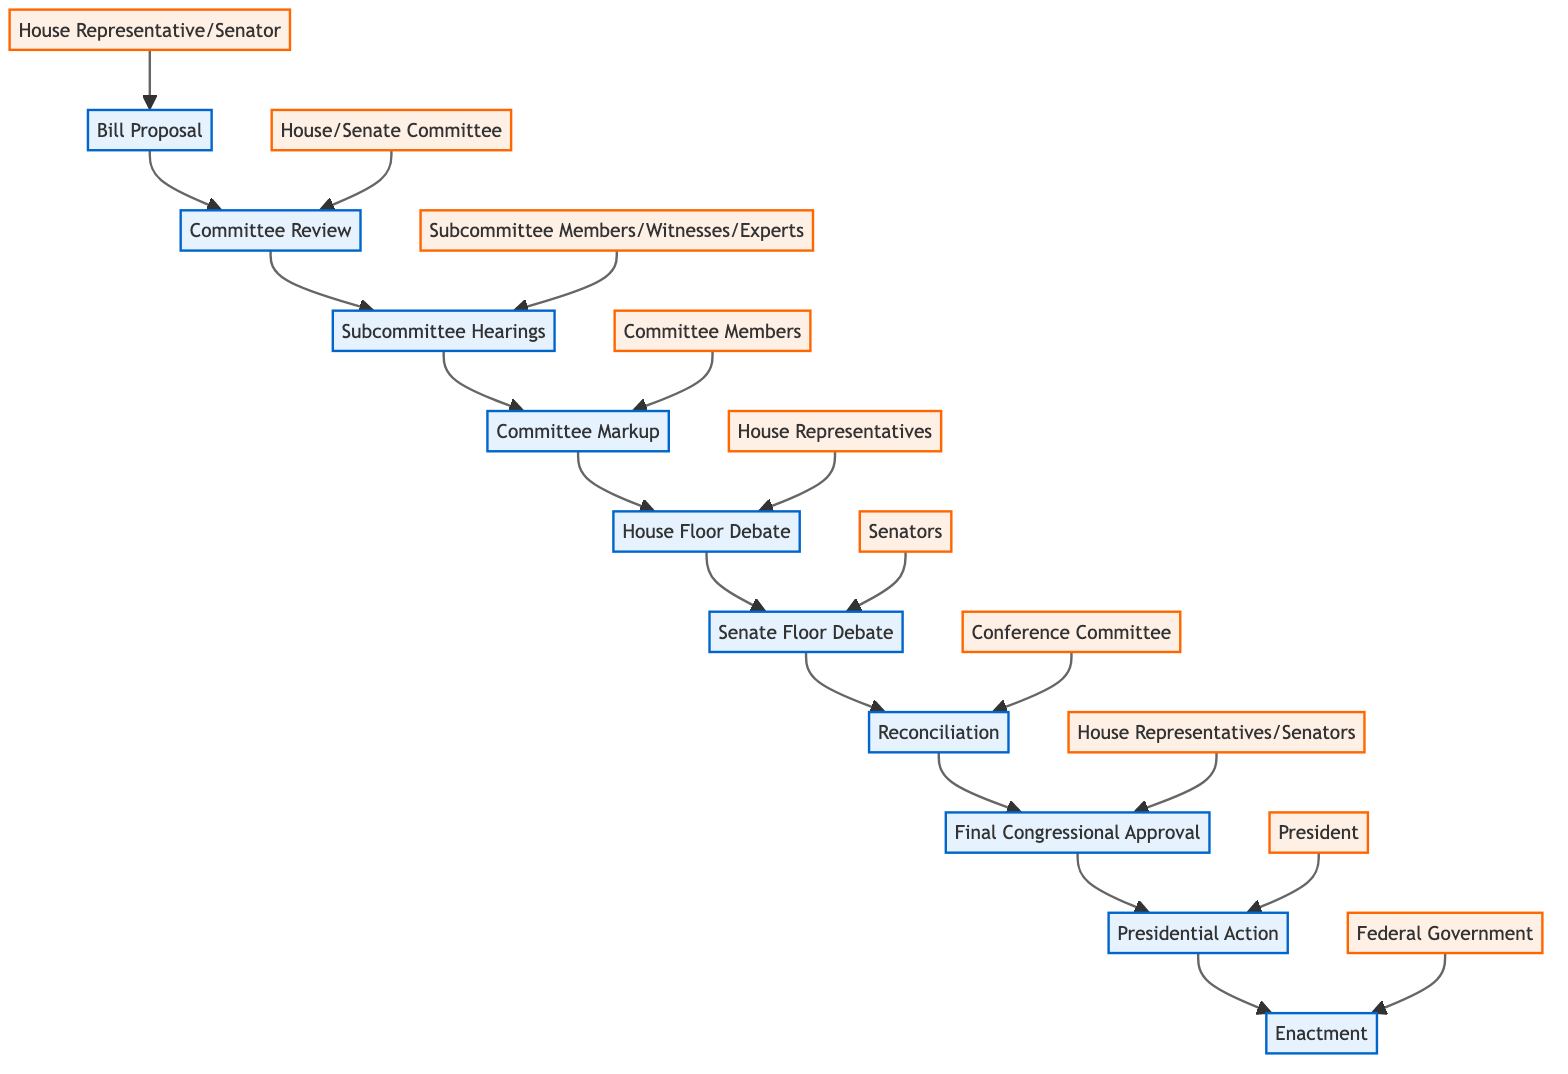What is the first stage of the legislative bill lifecycle? The first stage in the diagram is labeled "Bill Proposal," which is indicated as the starting point of the flow.
Answer: Bill Proposal How many stages are there from Bill Proposal to Enactment? The diagram shows a total of 10 distinct stages, starting from "Bill Proposal" and ending at "Enactment."
Answer: 10 Who is involved in the Committee Review stage? The actors listed for the Committee Review stage include "House Committee" and "Senate Committee," which directly connect to that stage in the flow.
Answer: House Committee, Senate Committee What comes after Committee Markup? Following the Committee Markup stage, the diagram indicates that the next stage is the "House Floor Debate," as visualized by the arrow connecting them in the flow.
Answer: House Floor Debate How many actors are involved in the Senate Floor Debate stage? The diagram states that "Senators" are the actors involved in the Senate Floor Debate stage, indicating there's only one group responsible for this stage.
Answer: Senators What is the relationship between Final Congressional Approval and Presidential Action? The relationship is sequential; "Final Congressional Approval" leads into "Presidential Action," showing that one stage must precede the other in the flow of the legislative process.
Answer: Sequential relationship What stage directly precedes Enactment? The stage that directly precedes "Enactment" is "Presidential Action," which is indicated by the arrow pointing from one to the other in the diagram.
Answer: Presidential Action Which committee is responsible for reconciling the bill? "Conference Committee" is shown in the diagram as the committee that reconciles differences between House and Senate versions of the bill.
Answer: Conference Committee How many distinct groups of actors are involved in the lifecycle of a legislative bill? The diagram outlines a total of 7 distinct groups of actors associated with various stages of the legislative process from proposal to enactment.
Answer: 7 